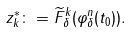<formula> <loc_0><loc_0><loc_500><loc_500>z _ { k } ^ { \ast } \colon = \widetilde { F } _ { \delta } ^ { k } ( \varphi _ { \delta } ^ { n } ( t _ { 0 } ) ) .</formula> 